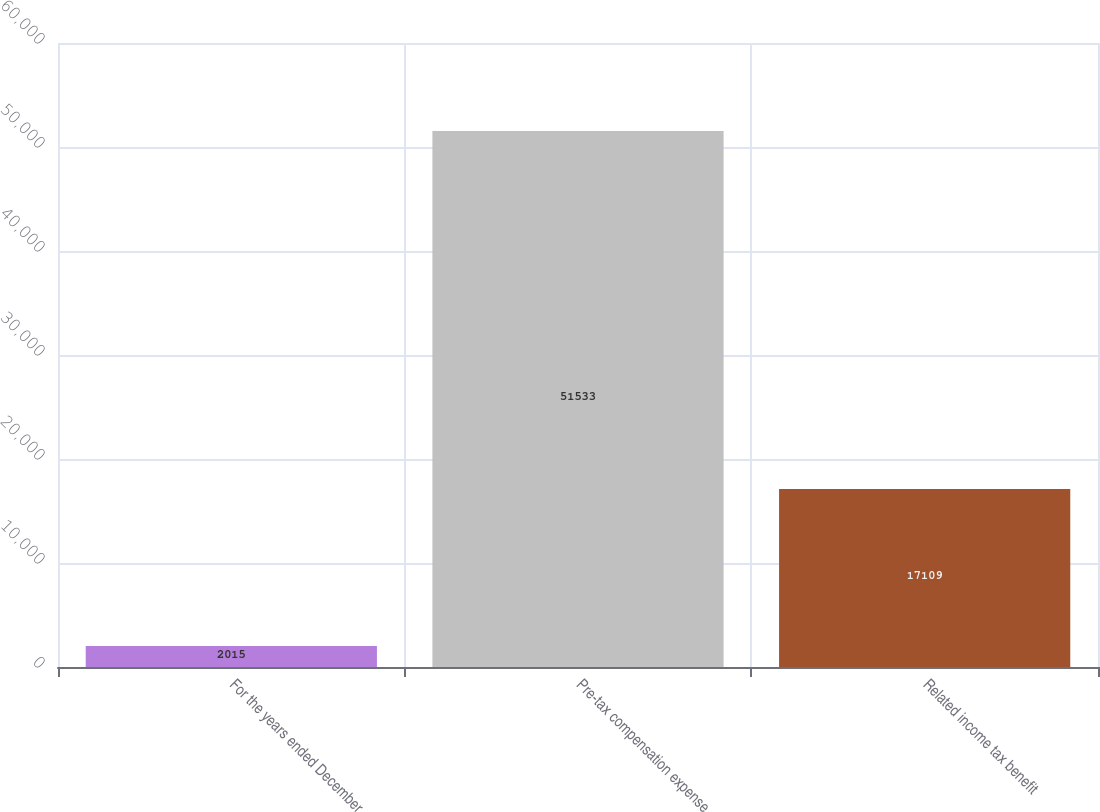Convert chart to OTSL. <chart><loc_0><loc_0><loc_500><loc_500><bar_chart><fcel>For the years ended December<fcel>Pre-tax compensation expense<fcel>Related income tax benefit<nl><fcel>2015<fcel>51533<fcel>17109<nl></chart> 